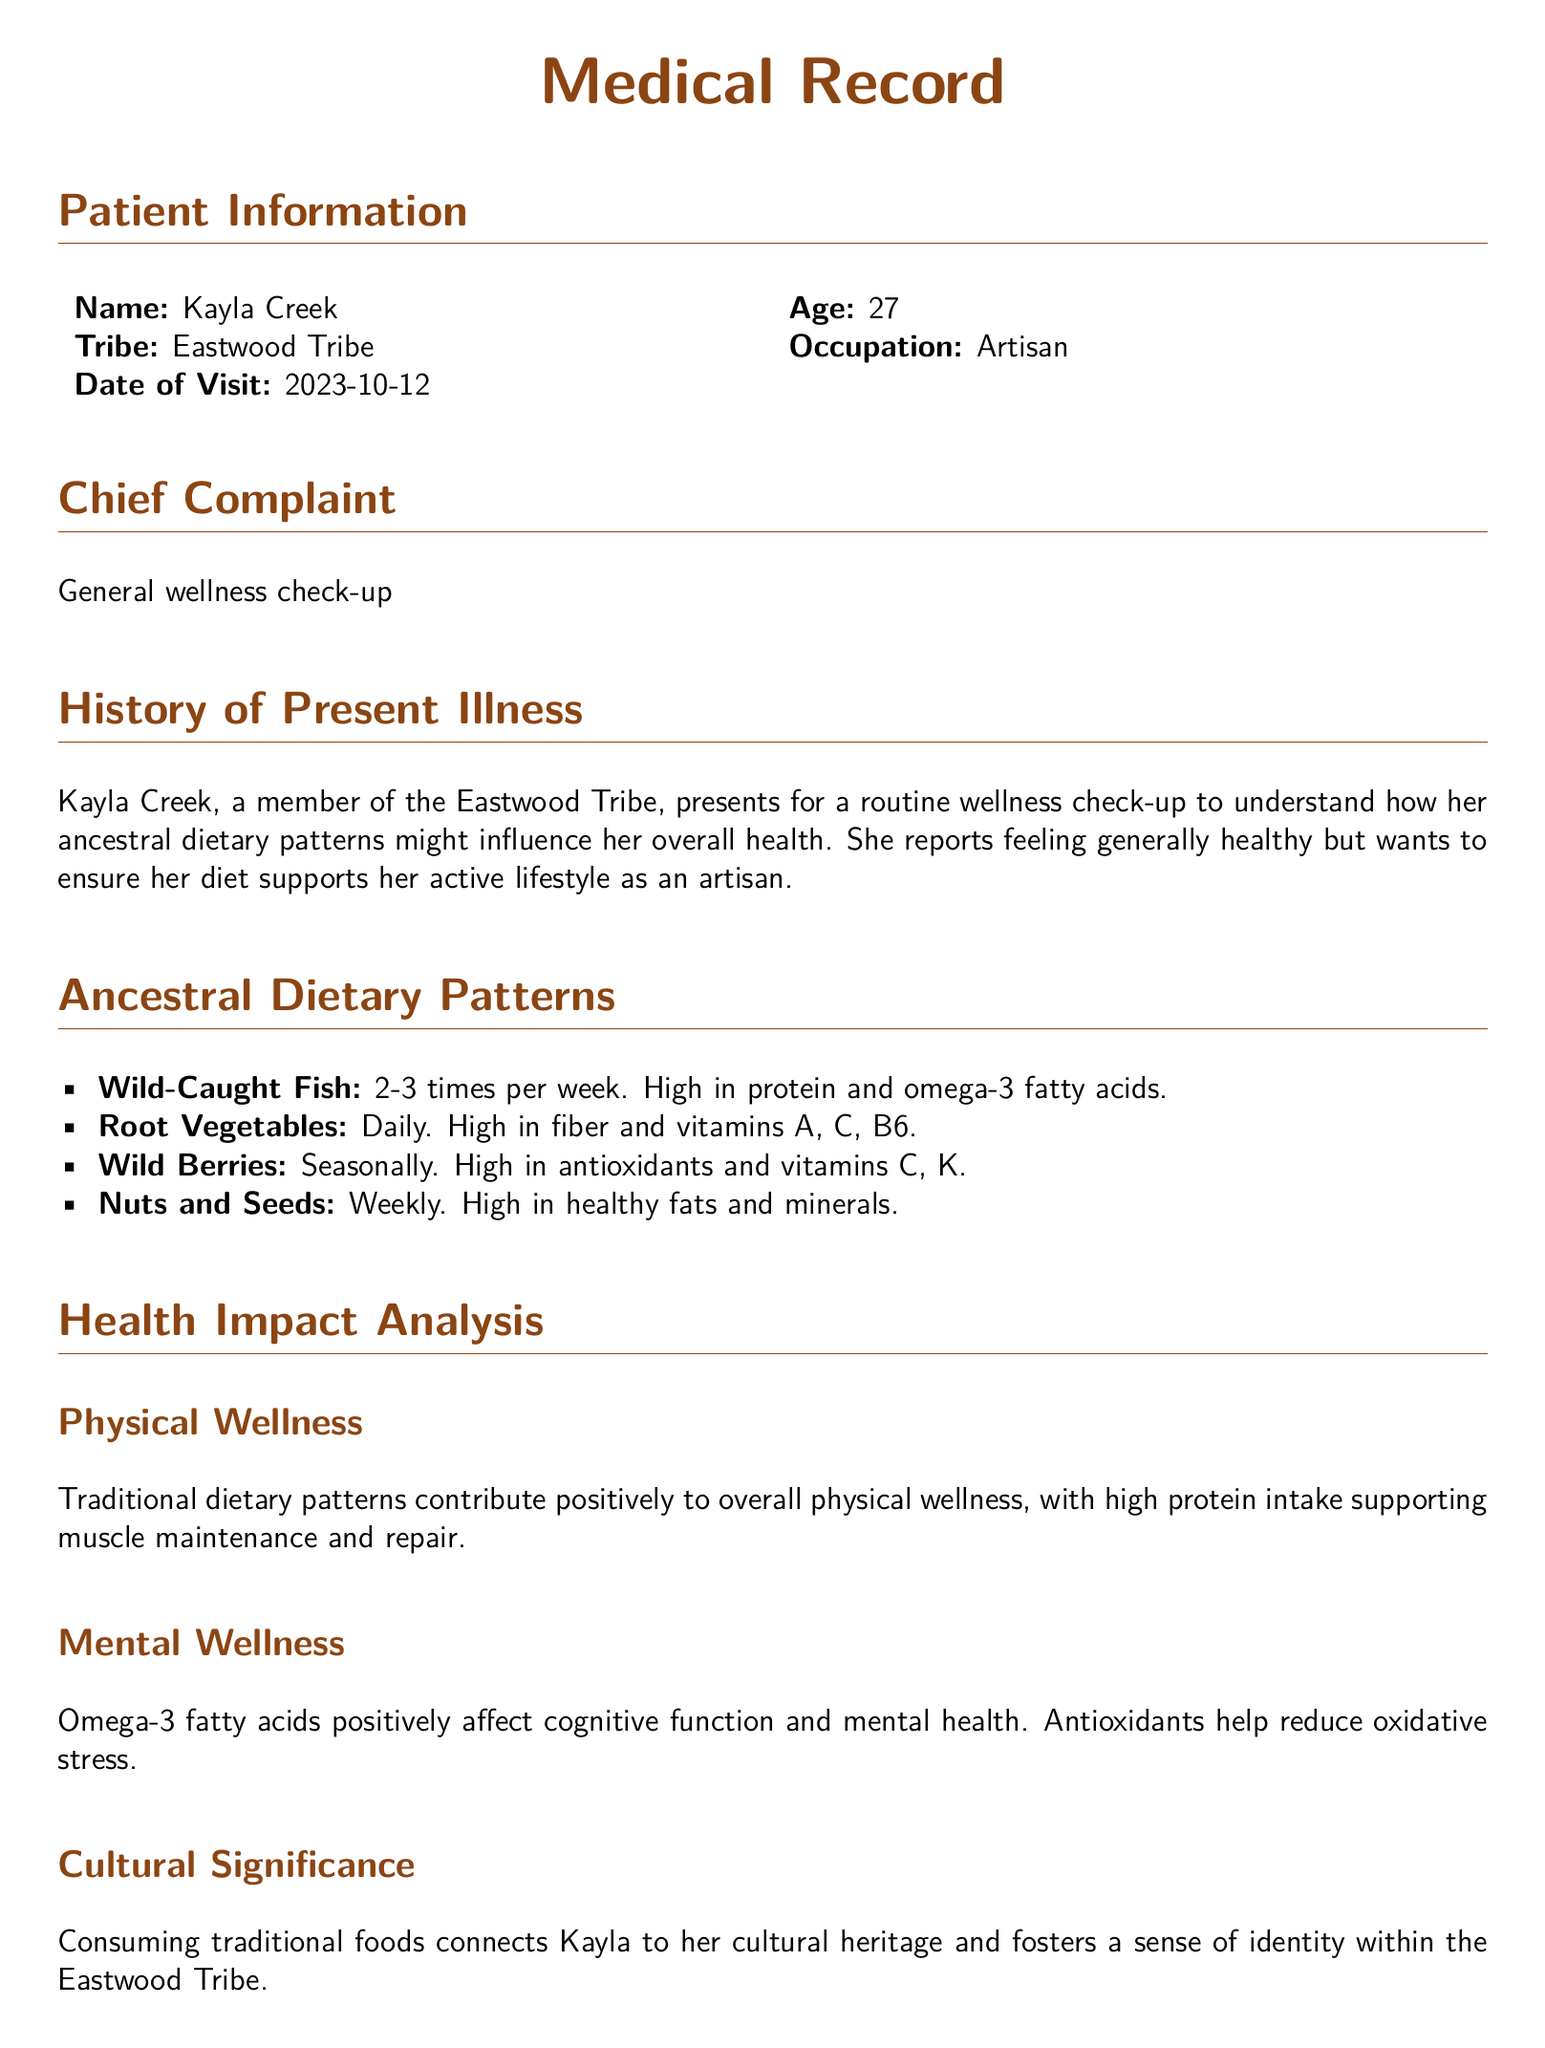What is the patient's name? The document states that the patient's name is Kayla Creek.
Answer: Kayla Creek How old is the patient? The document lists the patient's age as 27 years.
Answer: 27 What is the chief complaint? The chief complaint noted in the document is a general wellness check-up.
Answer: General wellness check-up How often does the patient consume wild-caught fish? The document specifies that the patient consumes wild-caught fish 2-3 times per week.
Answer: 2-3 times per week What are the benefits of omega-3 fatty acids mentioned? Omega-3 fatty acids are noted to positively affect cognitive function and mental health.
Answer: Cognitive function and mental health What is one recommendation made in the document? The document provides several recommendations, one being to increase the intake of leafy greens for bone health.
Answer: Increase intake of leafy greens What does the patient's adherence to ancestral dietary patterns contribute to? The document concludes that Kayla's adherence to these patterns significantly contributes to her overall wellness.
Answer: Overall wellness What type of document is this? The structured elements and content indicate that this is a medical record.
Answer: Medical record What is the cultural significance of traditional foods for the patient? The document states that consuming traditional foods connects Kayla to her cultural heritage and identity.
Answer: Cultural heritage and identity 